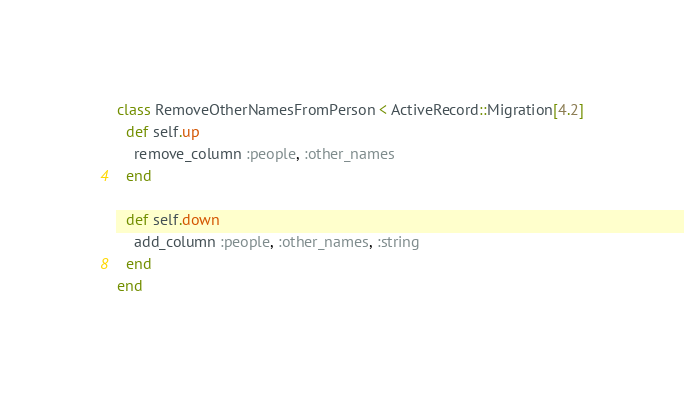<code> <loc_0><loc_0><loc_500><loc_500><_Ruby_>class RemoveOtherNamesFromPerson < ActiveRecord::Migration[4.2]
  def self.up
    remove_column :people, :other_names
  end

  def self.down
    add_column :people, :other_names, :string
  end
end
</code> 